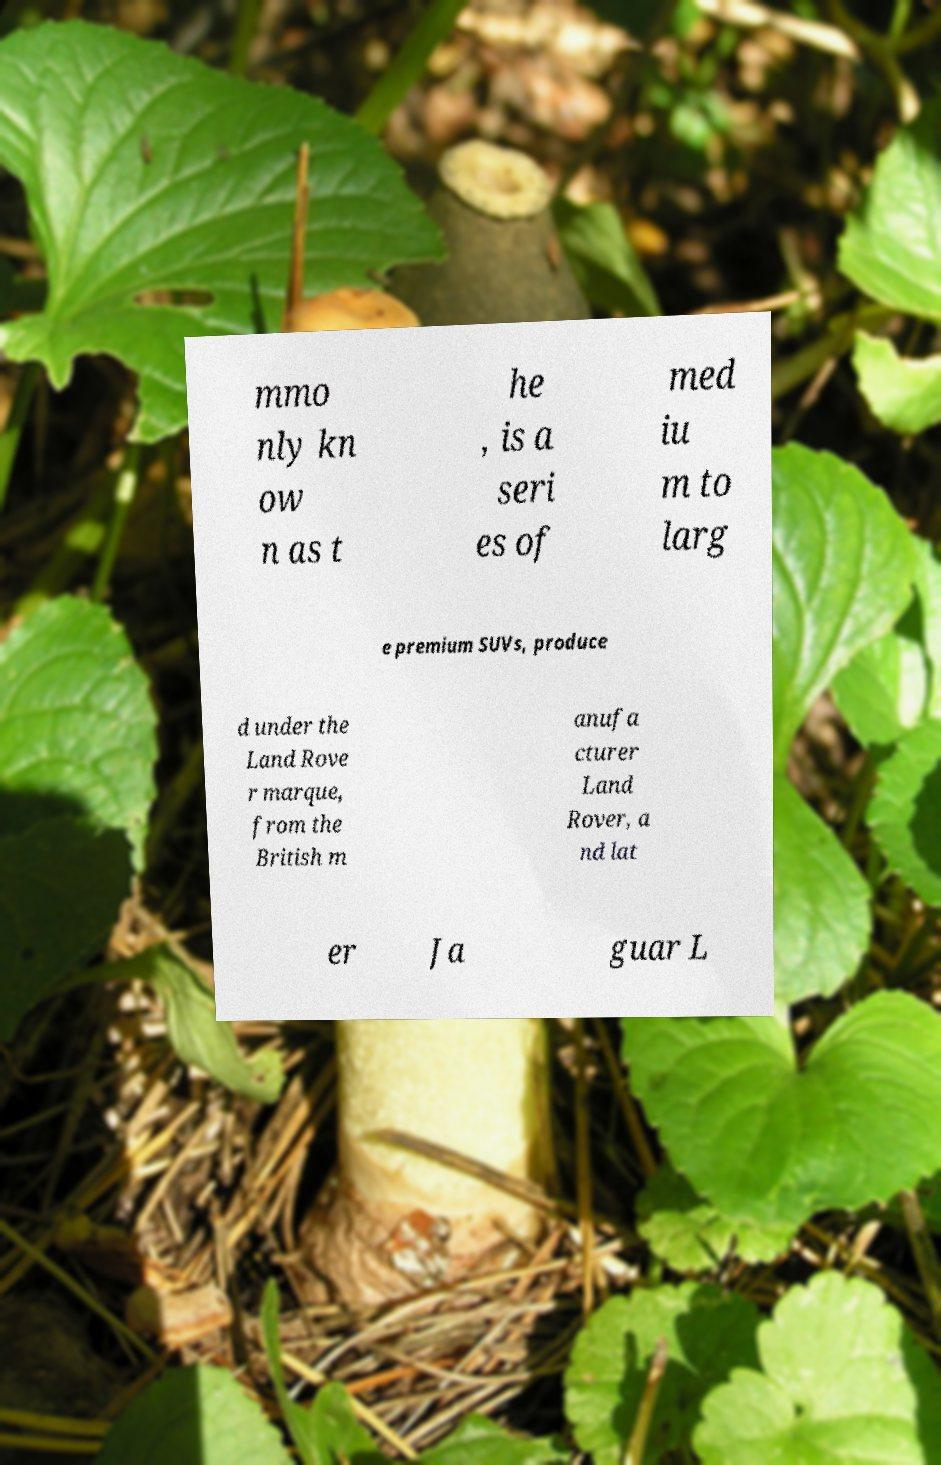I need the written content from this picture converted into text. Can you do that? mmo nly kn ow n as t he , is a seri es of med iu m to larg e premium SUVs, produce d under the Land Rove r marque, from the British m anufa cturer Land Rover, a nd lat er Ja guar L 